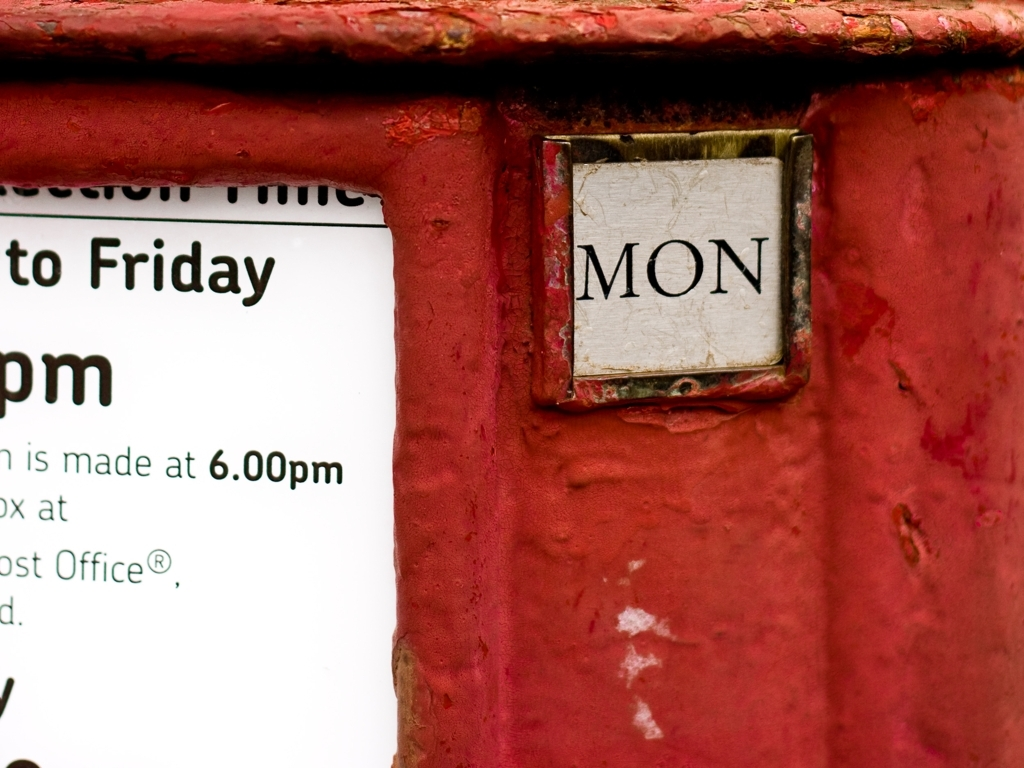Is the image quality poor?
A. Yes
B. No B. No, the image quality is not poor. The image is clear and the details, such as the text on the sign and the texture of the red surface, are perfectly discernible. 